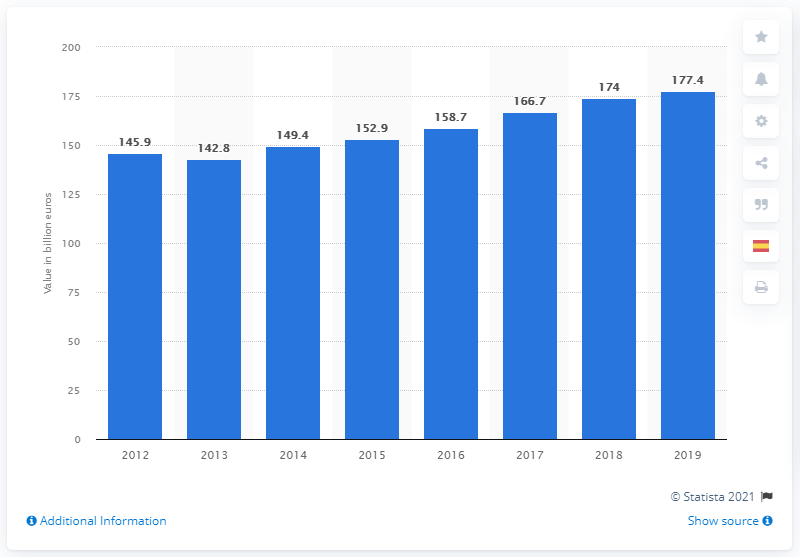Can you tell if there was a drop in Spain's GDP during any year shown in this chart? Yes, the chart indicates a slight drop in Spain's GDP from 2012 to 2013, decreasing from €1.459 trillion to €1.428 trillion. After 2013, the GDP figures show a year-on-year increase. 